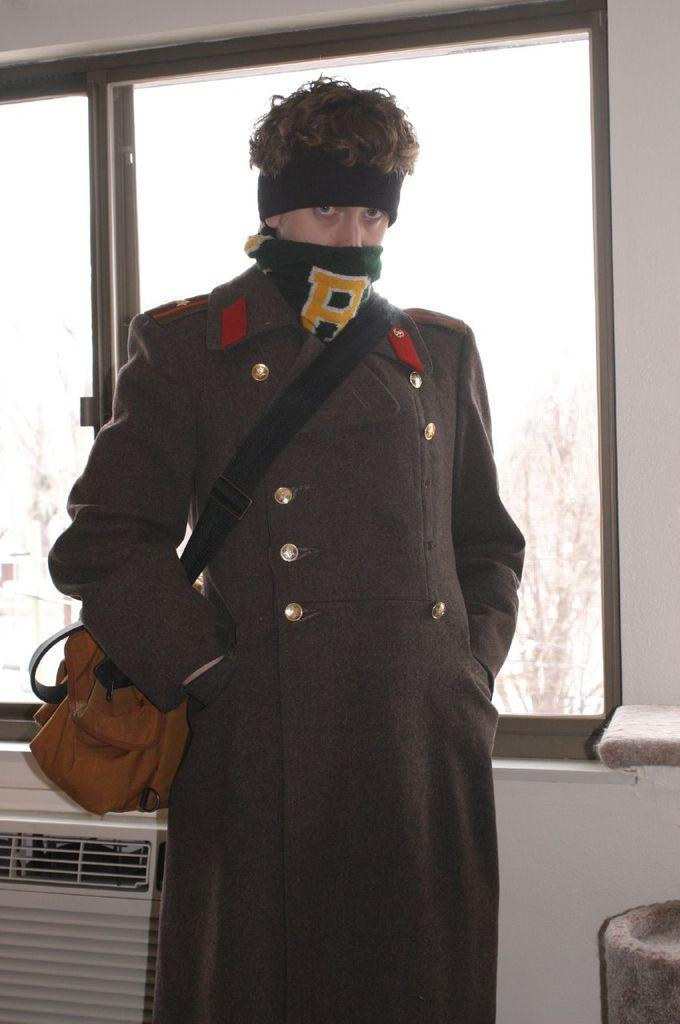What is the main subject in the foreground of the image? There is a man standing in the foreground of the image. What is the man wearing on his body? The man is wearing a bag and an overcoat. What can be seen in the background of the image? There is a wall, a glass window, and an AC in the background of the image. What type of rhythm does the man have while walking in the image? The image does not show the man walking, so it is not possible to determine his rhythm. 